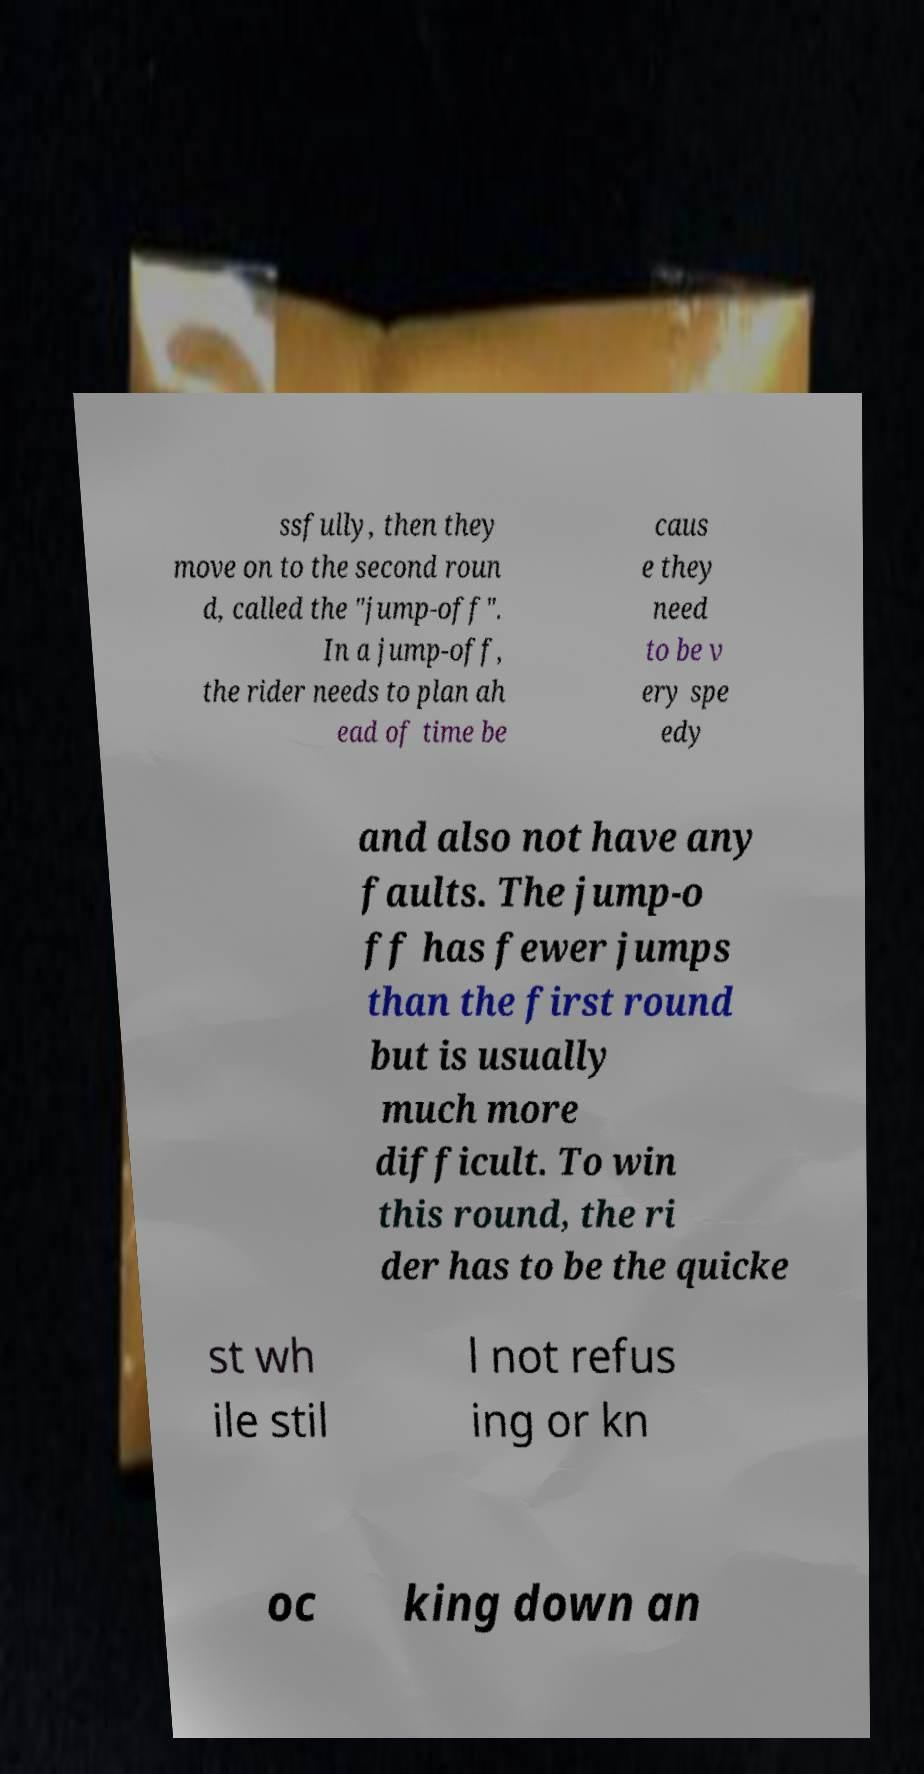Can you accurately transcribe the text from the provided image for me? ssfully, then they move on to the second roun d, called the "jump-off". In a jump-off, the rider needs to plan ah ead of time be caus e they need to be v ery spe edy and also not have any faults. The jump-o ff has fewer jumps than the first round but is usually much more difficult. To win this round, the ri der has to be the quicke st wh ile stil l not refus ing or kn oc king down an 